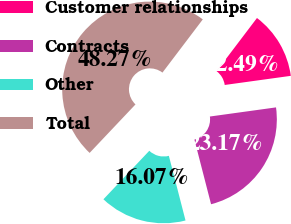Convert chart to OTSL. <chart><loc_0><loc_0><loc_500><loc_500><pie_chart><fcel>Customer relationships<fcel>Contracts<fcel>Other<fcel>Total<nl><fcel>12.49%<fcel>23.17%<fcel>16.07%<fcel>48.27%<nl></chart> 